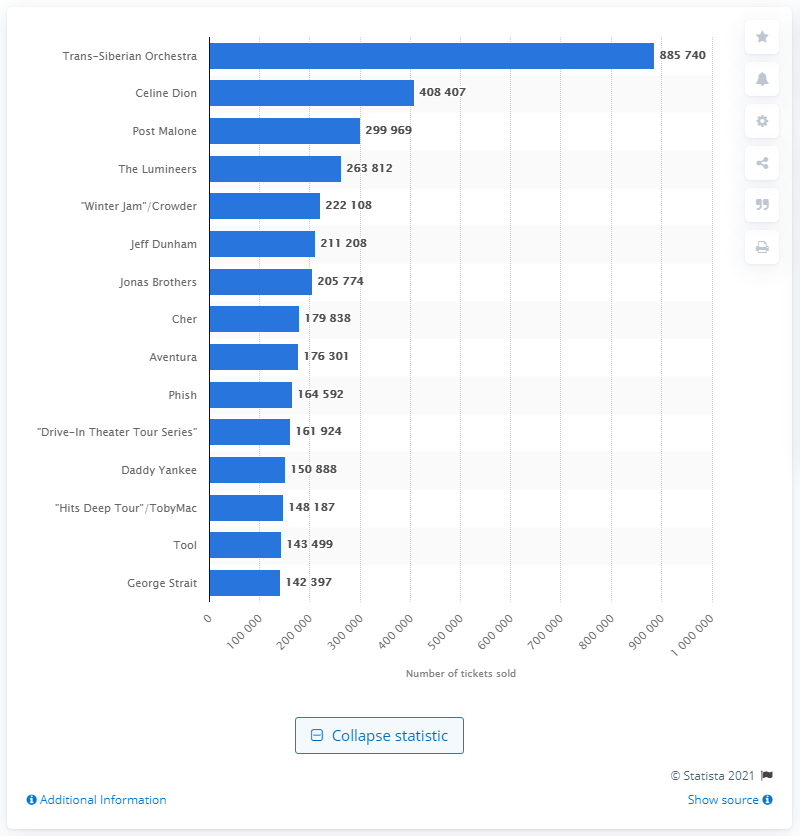Identify some key points in this picture. The Trans-Siberian Orchestra sold 885,740 tickets in 2020. The Trans-Siberian Orchestra's tour was the most successful, having sold over 885 thousand tickets. 